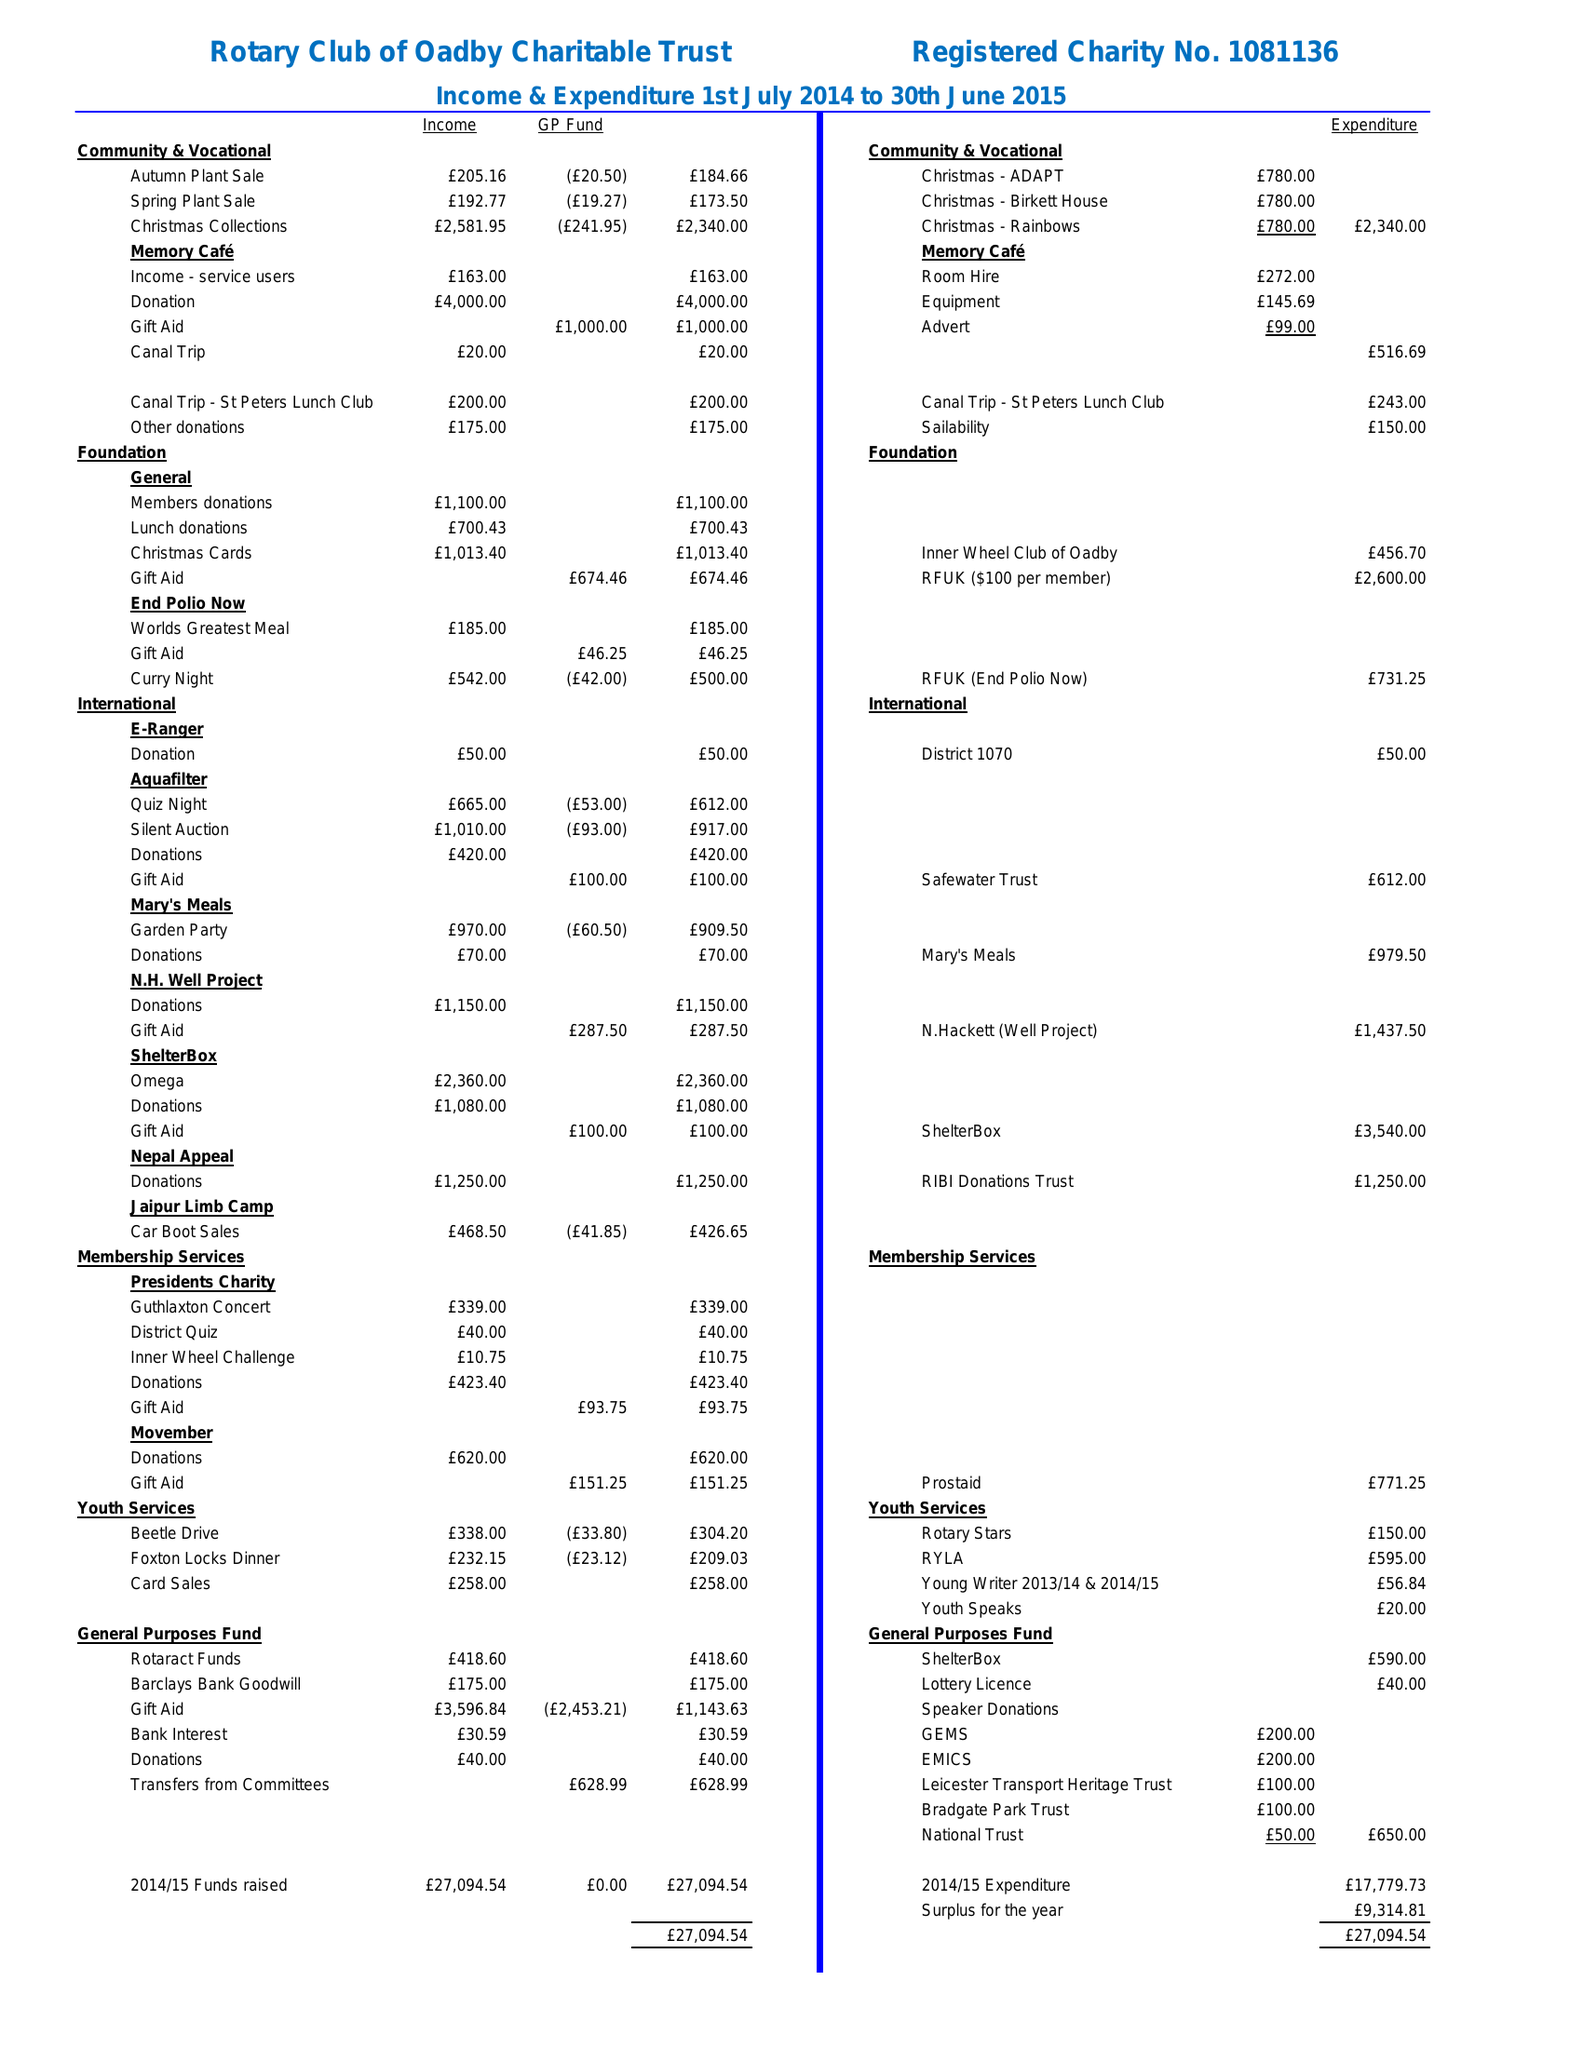What is the value for the address__street_line?
Answer the question using a single word or phrase. None 